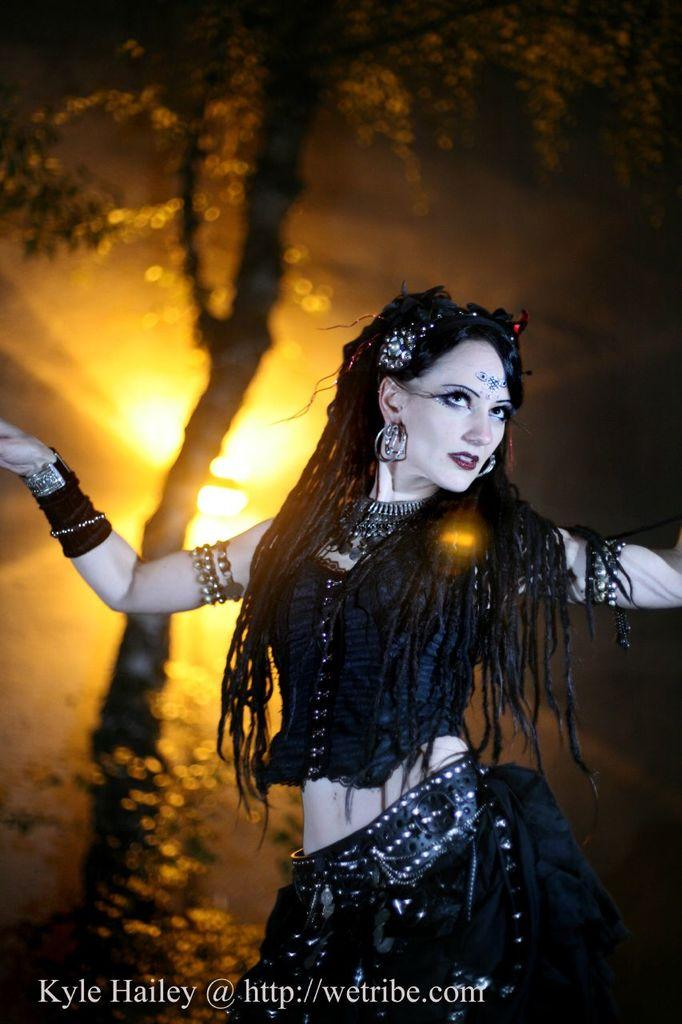Who is present in the image? There is a woman in the image. What can be found at the bottom of the image? There is text at the bottom of the image. What is visible in the background of the image? There is a tree and lights in the background of the image. What type of lock is used to secure the lamp in the image? There is no lock or lamp present in the image. What does the caption at the bottom of the image say? The provided facts do not mention a caption, only text at the bottom of the image. 